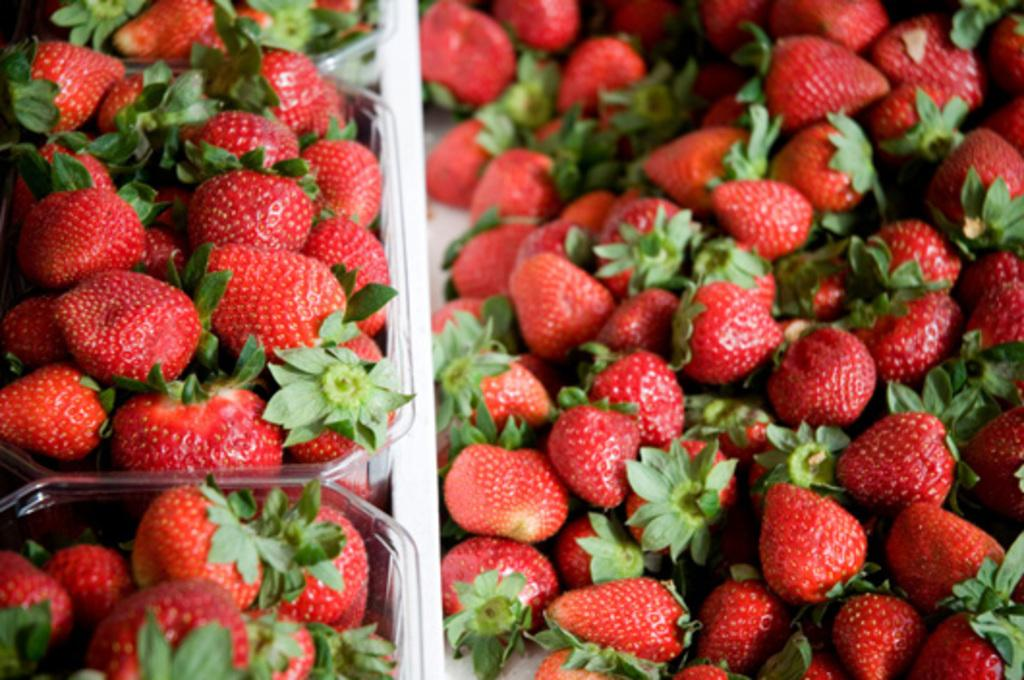What type of fruit is present in the image? There are many strawberries in the image. Where are the strawberries located? The strawberries are on a plastic box. What is the plastic box placed on? The plastic box is on a table. What type of lumber is visible in the image? There is no lumber present in the image; it features strawberries on a plastic box on a table. 